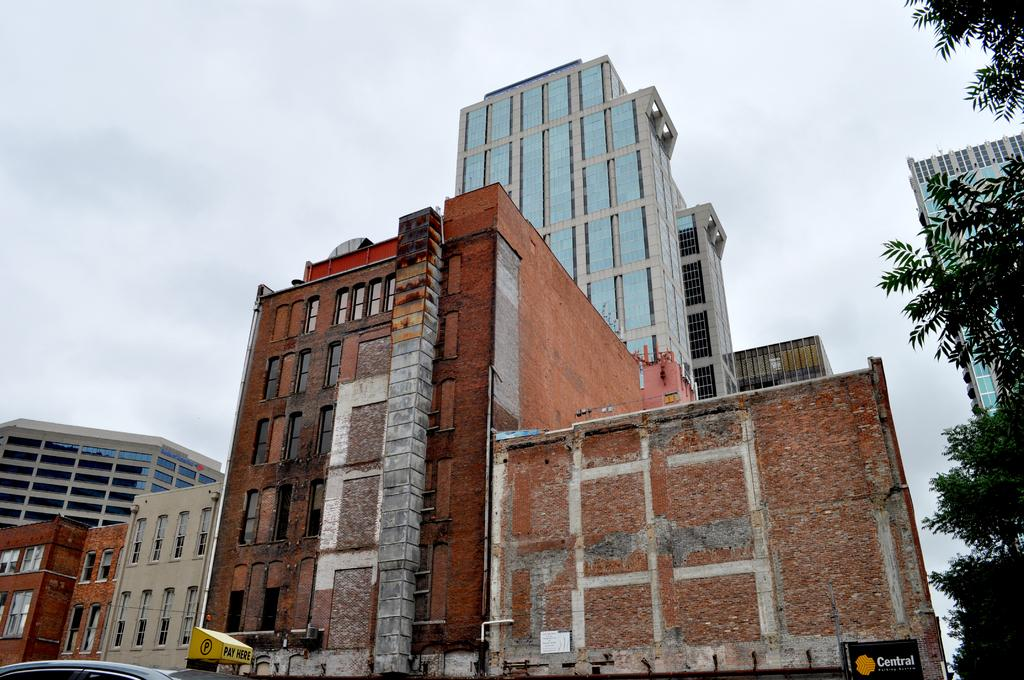What type of structures can be seen in the image? There are buildings in the image. What natural element is present on the right side of the image? There is a tree on the right side of the image. What mode of transportation is visible at the left bottom of the image? There is a vehicle at the left bottom of the image. What is visible at the top of the image? The sky is visible at the top of the image. Can you tell me how many grains of sand are on the tree in the image? There is no sand present in the image, and therefore no grains of sand can be counted on the tree. Is there a volleyball game happening in the image? There is no volleyball game or any reference to a volleyball in the image. 